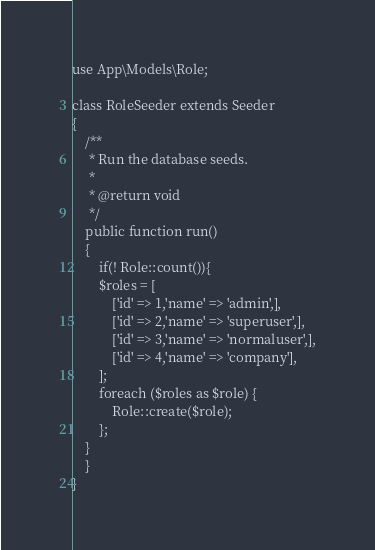Convert code to text. <code><loc_0><loc_0><loc_500><loc_500><_PHP_>use App\Models\Role;

class RoleSeeder extends Seeder
{
    /**
     * Run the database seeds.
     *
     * @return void
     */
    public function run()
    {
        if(! Role::count()){
        $roles = [
            ['id' => 1,'name' => 'admin',],
            ['id' => 2,'name' => 'superuser',],
            ['id' => 3,'name' => 'normaluser',],
            ['id' => 4,'name' => 'company'],
        ];
        foreach ($roles as $role) {
            Role::create($role);
        };
    }
    }
}
</code> 